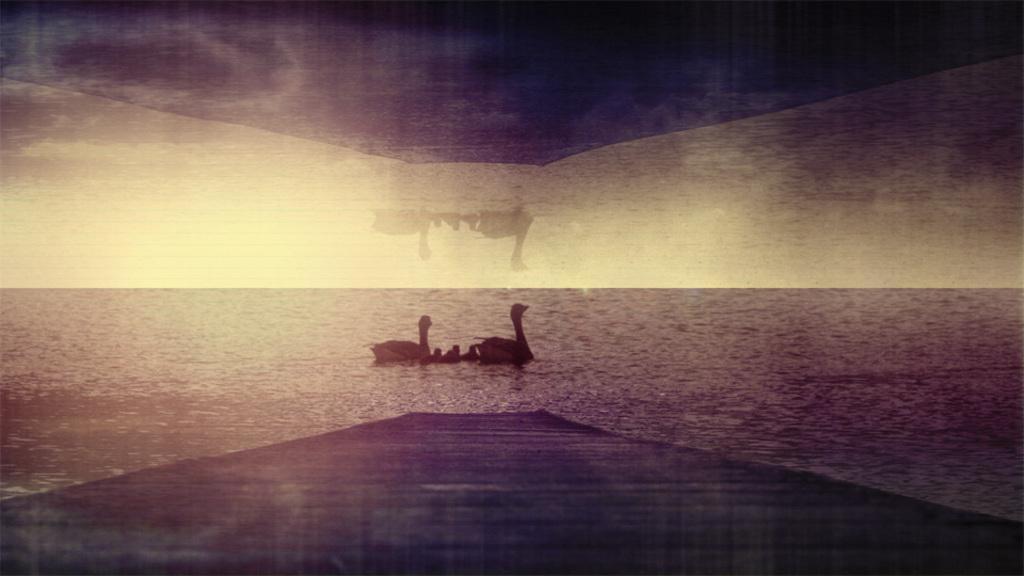In one or two sentences, can you explain what this image depicts? In this image we can see an edited picture of birds on the water. 